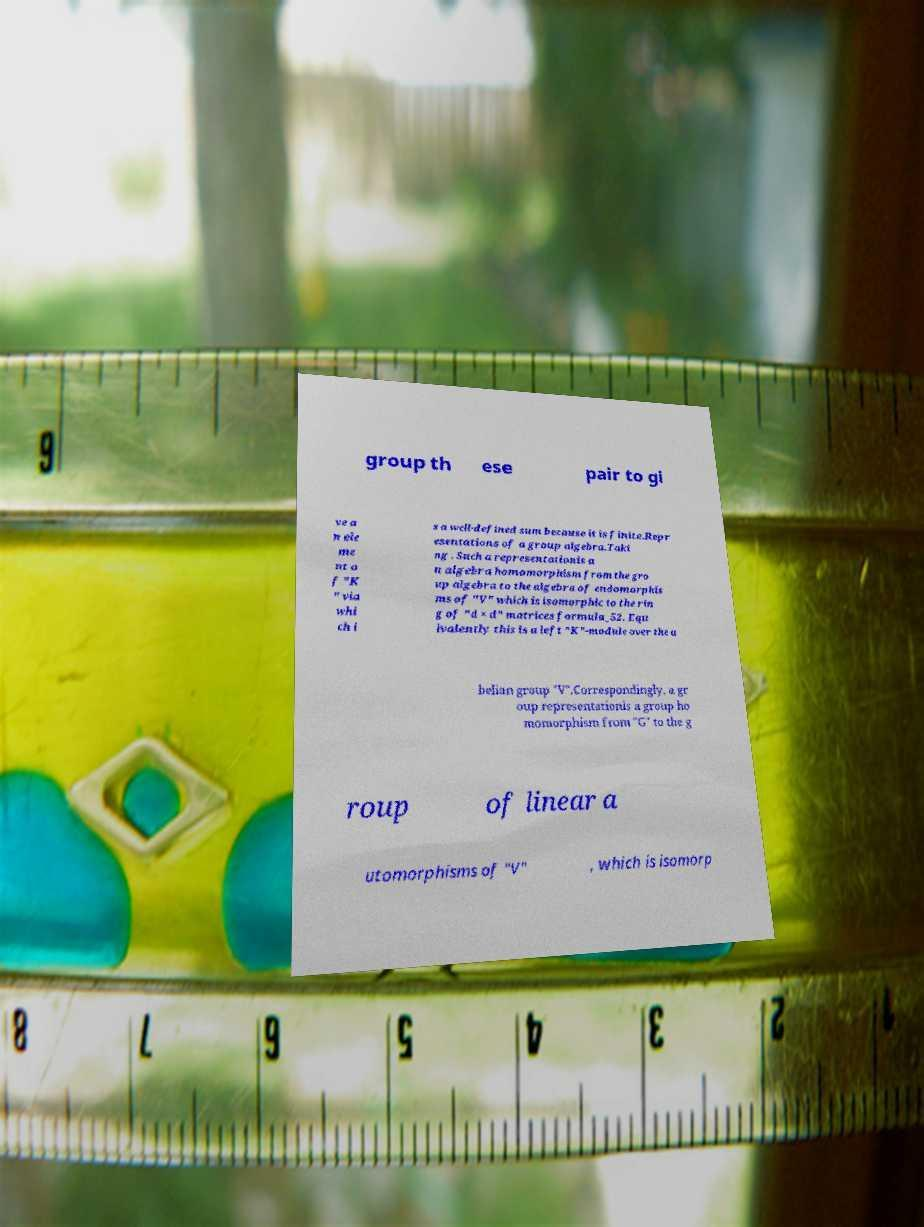Please identify and transcribe the text found in this image. group th ese pair to gi ve a n ele me nt o f "K " via whi ch i s a well-defined sum because it is finite.Repr esentations of a group algebra.Taki ng . Such a representationis a n algebra homomorphism from the gro up algebra to the algebra of endomorphis ms of "V" which is isomorphic to the rin g of "d × d" matrices formula_52. Equ ivalently this is a left "K"-module over the a belian group "V".Correspondingly, a gr oup representationis a group ho momorphism from "G" to the g roup of linear a utomorphisms of "V" , which is isomorp 